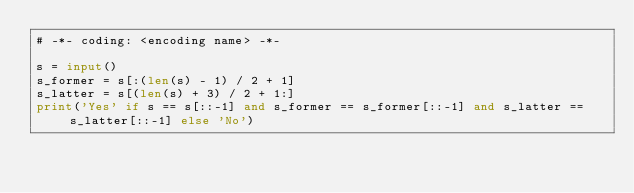Convert code to text. <code><loc_0><loc_0><loc_500><loc_500><_Python_># -*- coding: <encoding name> -*-

s = input()
s_former = s[:(len(s) - 1) / 2 + 1]
s_latter = s[(len(s) + 3) / 2 + 1:]
print('Yes' if s == s[::-1] and s_former == s_former[::-1] and s_latter == s_latter[::-1] else 'No')
</code> 